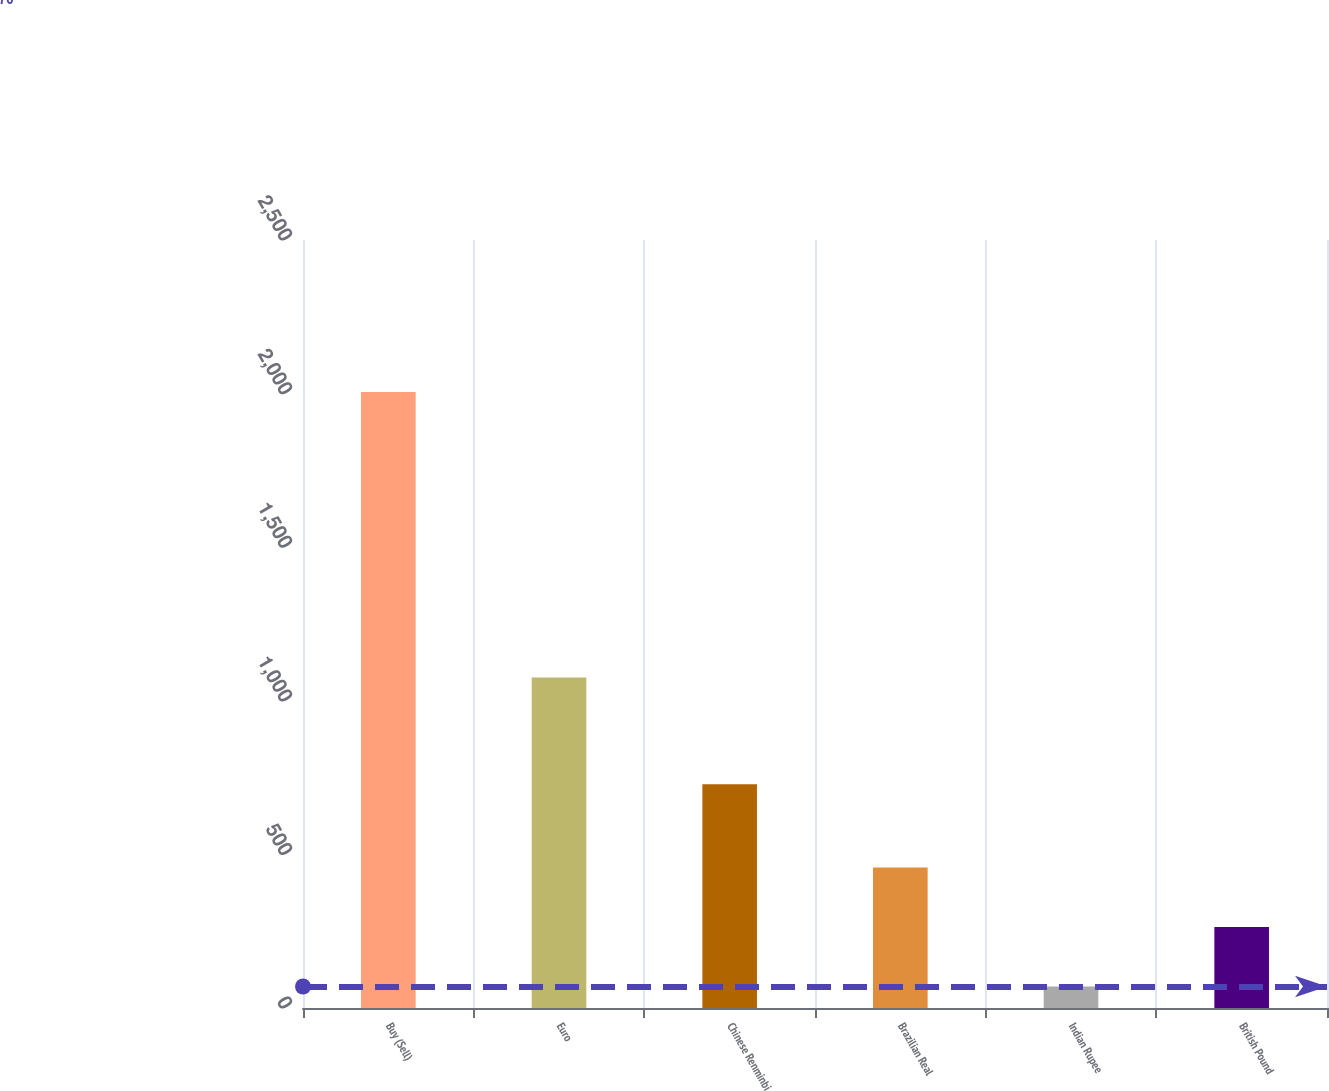Convert chart to OTSL. <chart><loc_0><loc_0><loc_500><loc_500><bar_chart><fcel>Buy (Sell)<fcel>Euro<fcel>Chinese Renminbi<fcel>Brazilian Real<fcel>Indian Rupee<fcel>British Pound<nl><fcel>2005<fcel>1076<fcel>728<fcel>457<fcel>70<fcel>263.5<nl></chart> 